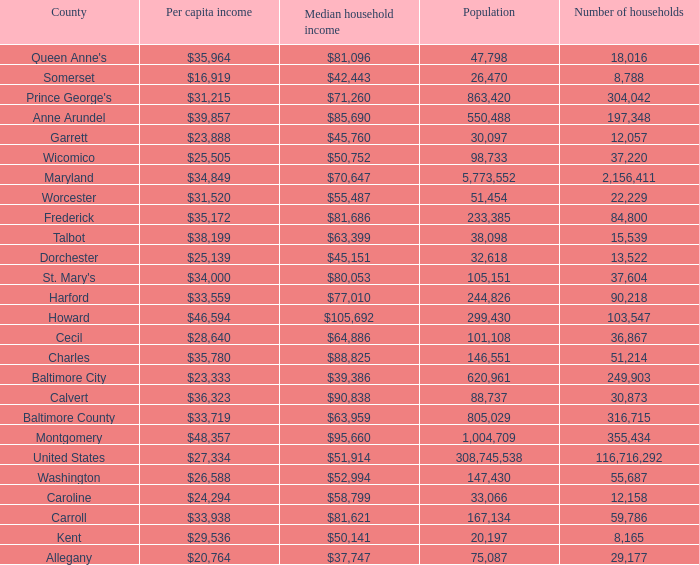Write the full table. {'header': ['County', 'Per capita income', 'Median household income', 'Population', 'Number of households'], 'rows': [["Queen Anne's", '$35,964', '$81,096', '47,798', '18,016'], ['Somerset', '$16,919', '$42,443', '26,470', '8,788'], ["Prince George's", '$31,215', '$71,260', '863,420', '304,042'], ['Anne Arundel', '$39,857', '$85,690', '550,488', '197,348'], ['Garrett', '$23,888', '$45,760', '30,097', '12,057'], ['Wicomico', '$25,505', '$50,752', '98,733', '37,220'], ['Maryland', '$34,849', '$70,647', '5,773,552', '2,156,411'], ['Worcester', '$31,520', '$55,487', '51,454', '22,229'], ['Frederick', '$35,172', '$81,686', '233,385', '84,800'], ['Talbot', '$38,199', '$63,399', '38,098', '15,539'], ['Dorchester', '$25,139', '$45,151', '32,618', '13,522'], ["St. Mary's", '$34,000', '$80,053', '105,151', '37,604'], ['Harford', '$33,559', '$77,010', '244,826', '90,218'], ['Howard', '$46,594', '$105,692', '299,430', '103,547'], ['Cecil', '$28,640', '$64,886', '101,108', '36,867'], ['Charles', '$35,780', '$88,825', '146,551', '51,214'], ['Baltimore City', '$23,333', '$39,386', '620,961', '249,903'], ['Calvert', '$36,323', '$90,838', '88,737', '30,873'], ['Baltimore County', '$33,719', '$63,959', '805,029', '316,715'], ['Montgomery', '$48,357', '$95,660', '1,004,709', '355,434'], ['United States', '$27,334', '$51,914', '308,745,538', '116,716,292'], ['Washington', '$26,588', '$52,994', '147,430', '55,687'], ['Caroline', '$24,294', '$58,799', '33,066', '12,158'], ['Carroll', '$33,938', '$81,621', '167,134', '59,786'], ['Kent', '$29,536', '$50,141', '20,197', '8,165'], ['Allegany', '$20,764', '$37,747', '75,087', '29,177']]} What is the per capital income for Charles county? $35,780. 